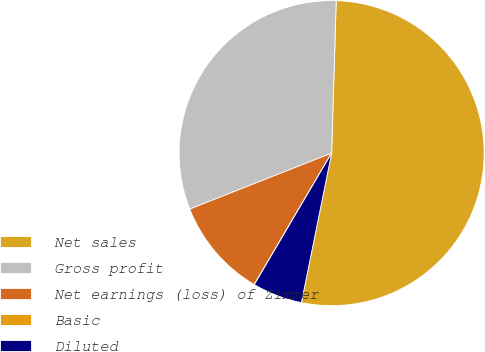<chart> <loc_0><loc_0><loc_500><loc_500><pie_chart><fcel>Net sales<fcel>Gross profit<fcel>Net earnings (loss) of Zimmer<fcel>Basic<fcel>Diluted<nl><fcel>52.69%<fcel>31.46%<fcel>10.55%<fcel>0.01%<fcel>5.28%<nl></chart> 